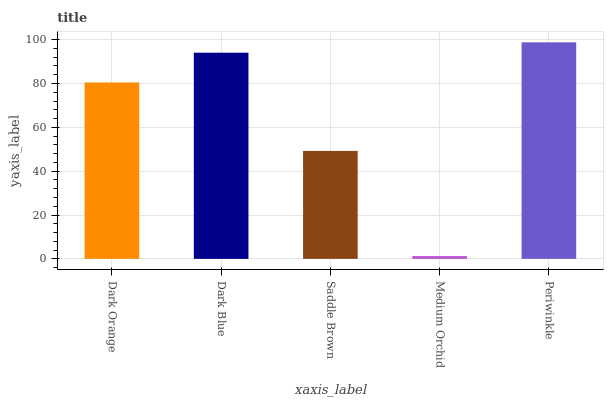Is Medium Orchid the minimum?
Answer yes or no. Yes. Is Periwinkle the maximum?
Answer yes or no. Yes. Is Dark Blue the minimum?
Answer yes or no. No. Is Dark Blue the maximum?
Answer yes or no. No. Is Dark Blue greater than Dark Orange?
Answer yes or no. Yes. Is Dark Orange less than Dark Blue?
Answer yes or no. Yes. Is Dark Orange greater than Dark Blue?
Answer yes or no. No. Is Dark Blue less than Dark Orange?
Answer yes or no. No. Is Dark Orange the high median?
Answer yes or no. Yes. Is Dark Orange the low median?
Answer yes or no. Yes. Is Dark Blue the high median?
Answer yes or no. No. Is Medium Orchid the low median?
Answer yes or no. No. 